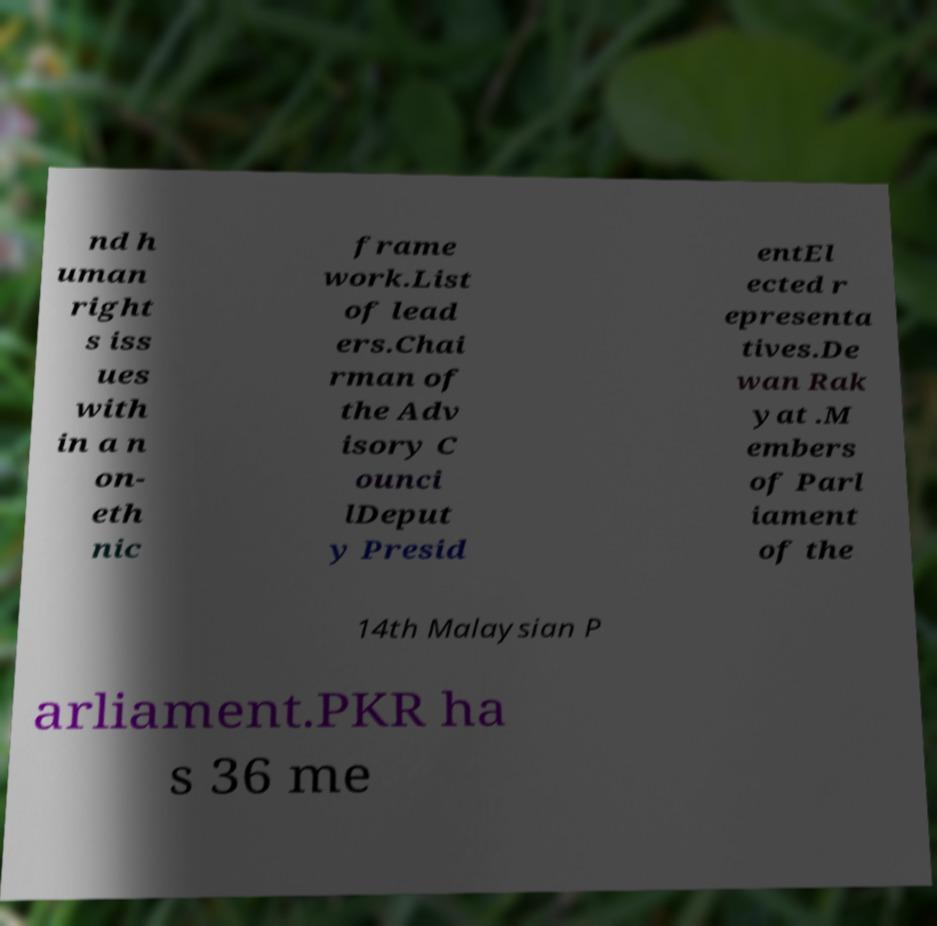What messages or text are displayed in this image? I need them in a readable, typed format. nd h uman right s iss ues with in a n on- eth nic frame work.List of lead ers.Chai rman of the Adv isory C ounci lDeput y Presid entEl ected r epresenta tives.De wan Rak yat .M embers of Parl iament of the 14th Malaysian P arliament.PKR ha s 36 me 